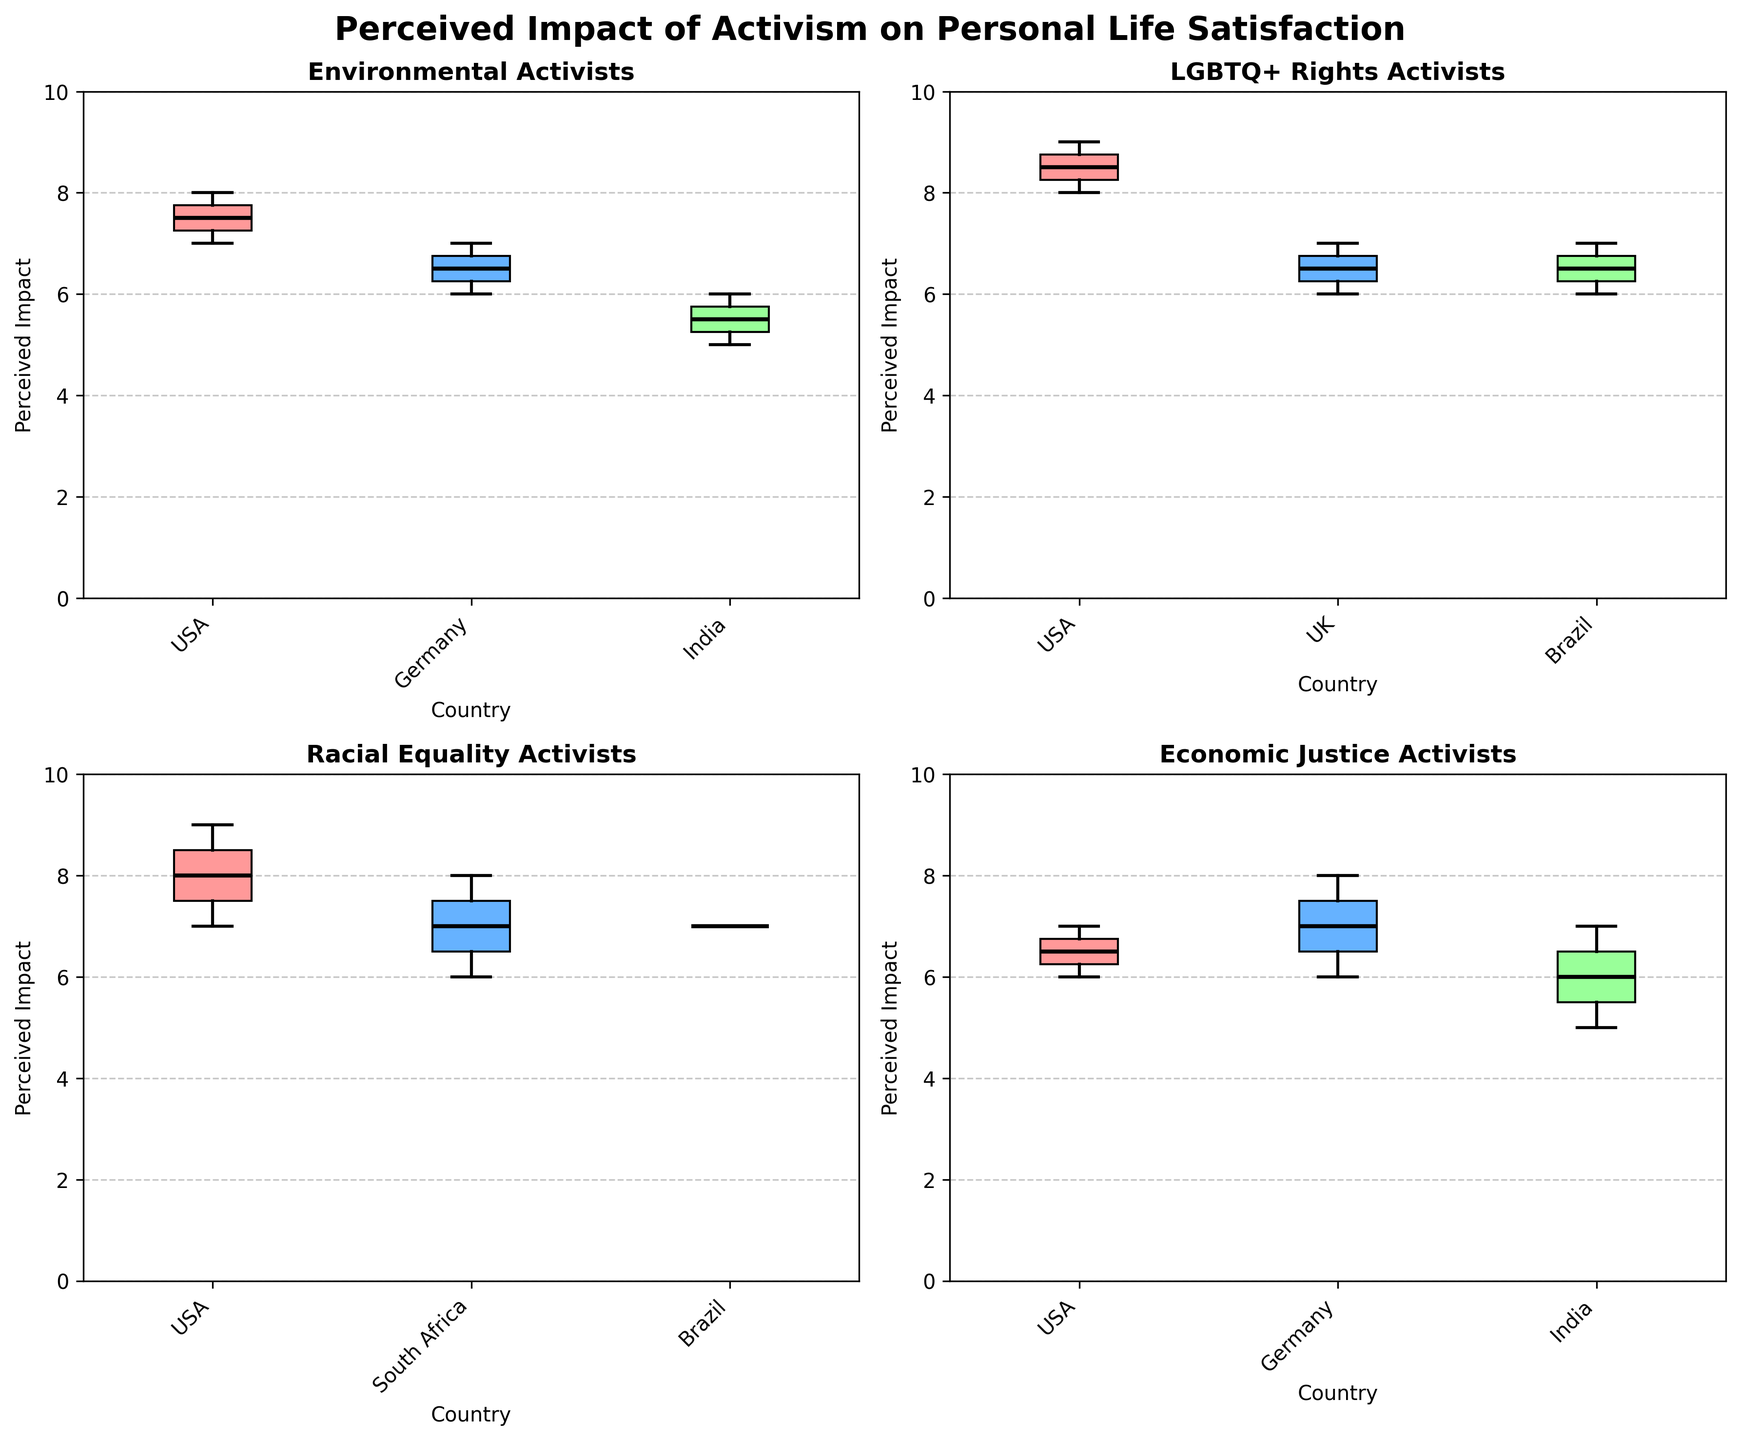what's the title of the figure? The title of the figure is displayed at the top of the plot. The title is generally bold and larger in font size compared to other text in the plot.
Answer: Perceived Impact of Activism on Personal Life Satisfaction Which group shows the highest median perceived impact? To determine the highest median perceived impact, look for the box plot with the highest central line (which represents the median) on the y-axis.
Answer: LGBTQ+ Rights Activists Which country has the widest range of perceived impacts for Economic Justice Activists? The widest range can be identified by looking at the length of the whiskers in the box plot for each country. Find the plot where the whiskers cover the largest range on the y-axis.
Answer: India How does the median perceived impact of Environmental Activists in the USA compare to those in Germany? Locate the median lines for Environmental Activists in both the USA and Germany. Compare their positions on the y-axis to determine which is higher or lower.
Answer: Germany is lower than the USA Which group and country combination has the lowest median perceived impact? Identify the box plot with the lowest central line (median) across all the group and country combinations.
Answer: Economic Justice Activists in India Which groups have perceived impacts that extend to the maximum value of 10? Look for box plots where the top whisker reaches or exceeds the value of 10 on the y-axis.
Answer: None Is there a noticeable difference in perceived impacts between male and female Environmental Activists? You would need to check the spread and median lines of box plots for male and female Environmental Activists in different countries to see if there's a visual disparity.
Answer: No In which countries do LGBTQ+ Rights Activists have a median perceived impact greater than 7? Check the box plots of LGBTQ+ Rights Activists for each country. Countries where the central median line is above 7 on the y-axis fit the criteria.
Answer: USA and UK How often do the median perceived impacts exceed 8 across all groups and countries? Count the number of box plots where the median line is above 8 on the y-axis.
Answer: 3 times 